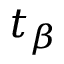<formula> <loc_0><loc_0><loc_500><loc_500>t _ { \beta }</formula> 